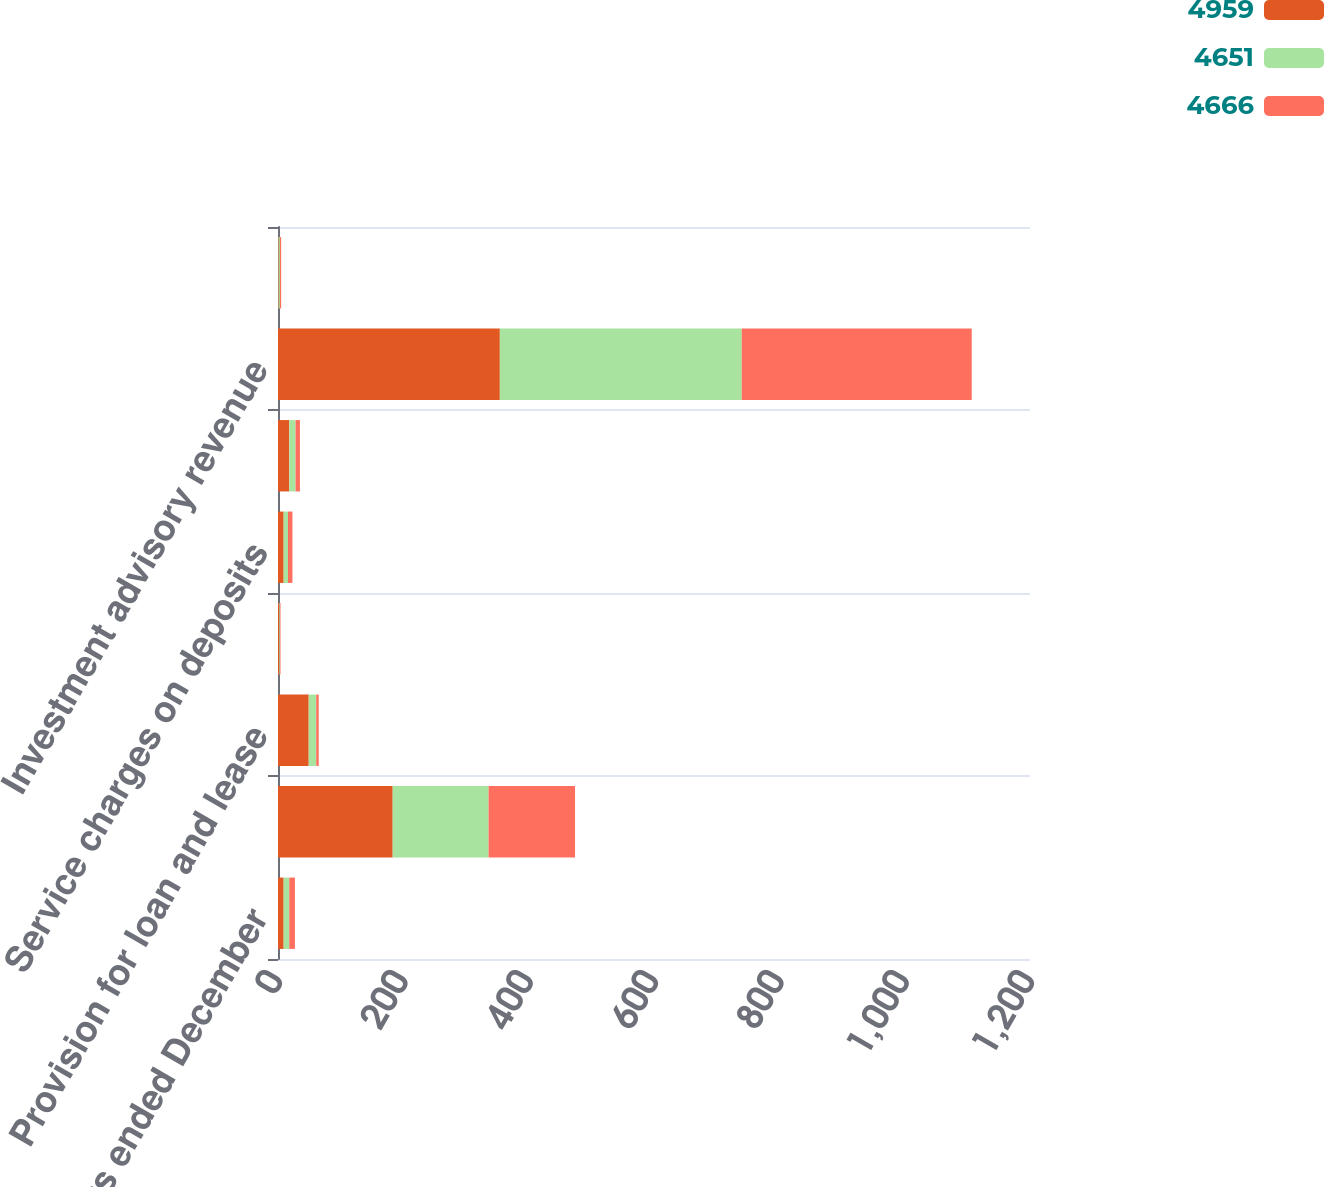<chart> <loc_0><loc_0><loc_500><loc_500><stacked_bar_chart><ecel><fcel>For the years ended December<fcel>Net interest income<fcel>Provision for loan and lease<fcel>Electronic payment processing<fcel>Service charges on deposits<fcel>Corporate banking revenue<fcel>Investment advisory revenue<fcel>Mortgage banking net revenue<nl><fcel>4959<fcel>9<fcel>183<fcel>49<fcel>2<fcel>9<fcel>18<fcel>354<fcel>1<nl><fcel>4651<fcel>9<fcel>153<fcel>12<fcel>1<fcel>7<fcel>10<fcel>386<fcel>2<nl><fcel>4666<fcel>9<fcel>138<fcel>4<fcel>1<fcel>7<fcel>7<fcel>367<fcel>2<nl></chart> 